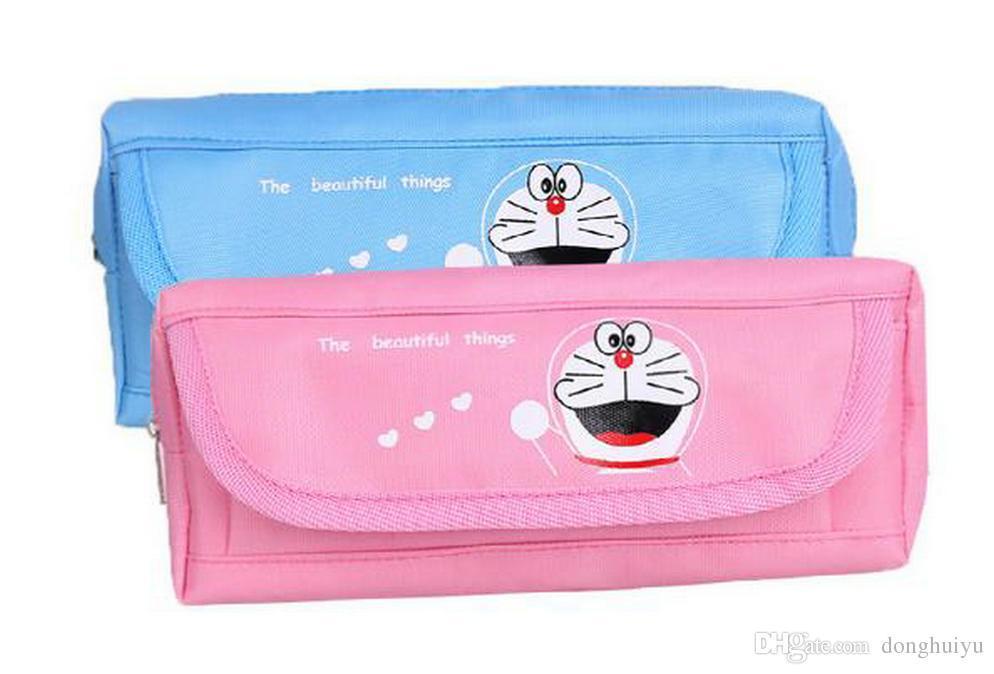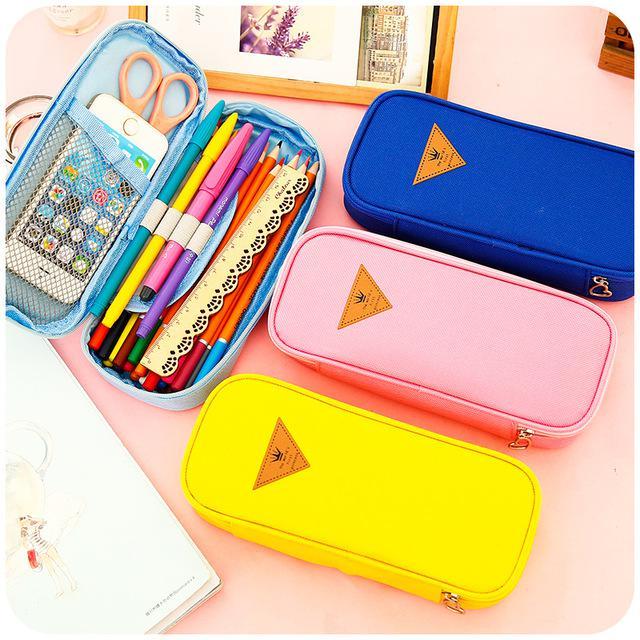The first image is the image on the left, the second image is the image on the right. For the images displayed, is the sentence "In one image, a wooden pencil case has a drawer pulled out to reveal stowed items and the top raised to show writing tools and a small blackboard with writing on it." factually correct? Answer yes or no. No. 